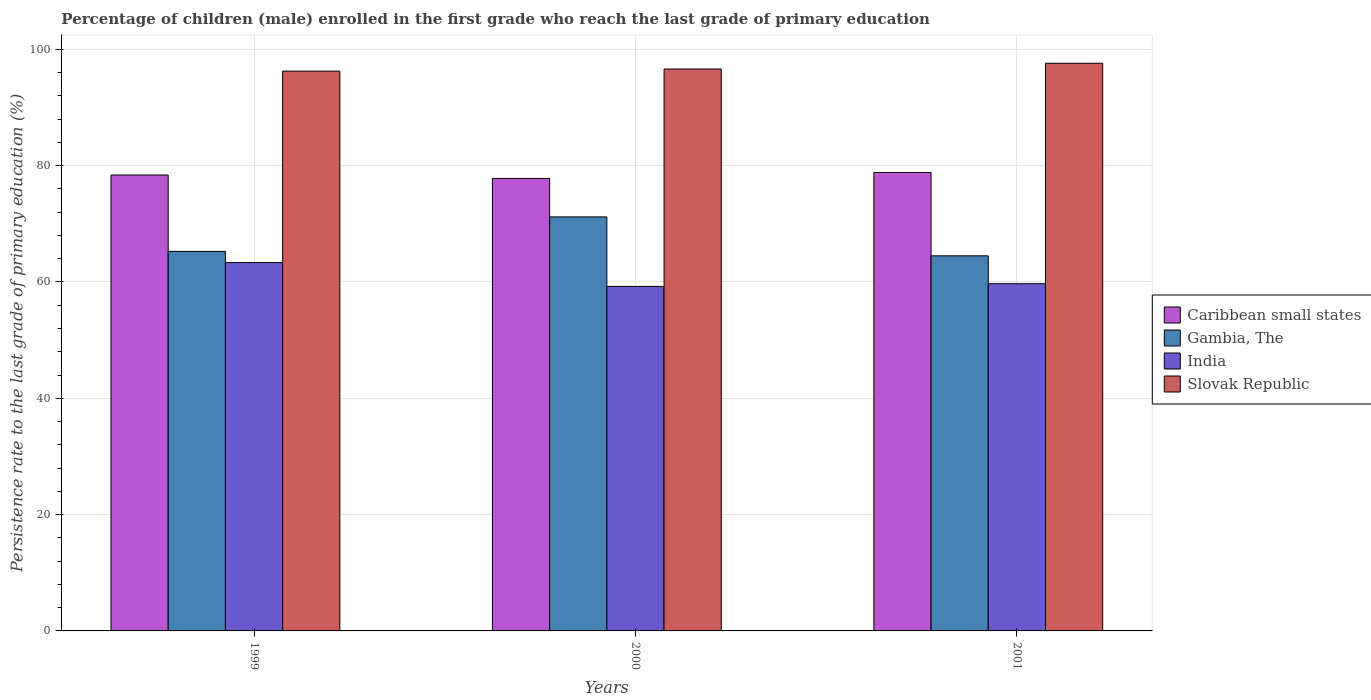Are the number of bars per tick equal to the number of legend labels?
Ensure brevity in your answer.  Yes. How many bars are there on the 3rd tick from the right?
Your response must be concise. 4. What is the persistence rate of children in Gambia, The in 2001?
Your answer should be very brief. 64.49. Across all years, what is the maximum persistence rate of children in Slovak Republic?
Offer a terse response. 97.6. Across all years, what is the minimum persistence rate of children in Gambia, The?
Your response must be concise. 64.49. What is the total persistence rate of children in India in the graph?
Provide a succinct answer. 182.26. What is the difference between the persistence rate of children in Gambia, The in 1999 and that in 2000?
Offer a terse response. -5.93. What is the difference between the persistence rate of children in India in 2000 and the persistence rate of children in Caribbean small states in 2001?
Keep it short and to the point. -19.59. What is the average persistence rate of children in Gambia, The per year?
Ensure brevity in your answer.  66.98. In the year 2000, what is the difference between the persistence rate of children in Gambia, The and persistence rate of children in Caribbean small states?
Offer a terse response. -6.61. In how many years, is the persistence rate of children in Slovak Republic greater than 48 %?
Make the answer very short. 3. What is the ratio of the persistence rate of children in Gambia, The in 2000 to that in 2001?
Provide a short and direct response. 1.1. Is the persistence rate of children in Caribbean small states in 1999 less than that in 2000?
Offer a very short reply. No. Is the difference between the persistence rate of children in Gambia, The in 2000 and 2001 greater than the difference between the persistence rate of children in Caribbean small states in 2000 and 2001?
Your response must be concise. Yes. What is the difference between the highest and the second highest persistence rate of children in Caribbean small states?
Your answer should be very brief. 0.44. What is the difference between the highest and the lowest persistence rate of children in Slovak Republic?
Ensure brevity in your answer.  1.35. In how many years, is the persistence rate of children in Gambia, The greater than the average persistence rate of children in Gambia, The taken over all years?
Your response must be concise. 1. What does the 4th bar from the left in 2000 represents?
Make the answer very short. Slovak Republic. What does the 2nd bar from the right in 2000 represents?
Ensure brevity in your answer.  India. Is it the case that in every year, the sum of the persistence rate of children in India and persistence rate of children in Gambia, The is greater than the persistence rate of children in Slovak Republic?
Offer a terse response. Yes. What is the difference between two consecutive major ticks on the Y-axis?
Give a very brief answer. 20. Does the graph contain any zero values?
Give a very brief answer. No. Does the graph contain grids?
Keep it short and to the point. Yes. How many legend labels are there?
Give a very brief answer. 4. What is the title of the graph?
Your response must be concise. Percentage of children (male) enrolled in the first grade who reach the last grade of primary education. What is the label or title of the X-axis?
Make the answer very short. Years. What is the label or title of the Y-axis?
Offer a terse response. Persistence rate to the last grade of primary education (%). What is the Persistence rate to the last grade of primary education (%) of Caribbean small states in 1999?
Offer a terse response. 78.39. What is the Persistence rate to the last grade of primary education (%) in Gambia, The in 1999?
Offer a terse response. 65.26. What is the Persistence rate to the last grade of primary education (%) of India in 1999?
Offer a terse response. 63.33. What is the Persistence rate to the last grade of primary education (%) in Slovak Republic in 1999?
Give a very brief answer. 96.26. What is the Persistence rate to the last grade of primary education (%) of Caribbean small states in 2000?
Provide a short and direct response. 77.79. What is the Persistence rate to the last grade of primary education (%) in Gambia, The in 2000?
Your answer should be very brief. 71.19. What is the Persistence rate to the last grade of primary education (%) of India in 2000?
Give a very brief answer. 59.23. What is the Persistence rate to the last grade of primary education (%) of Slovak Republic in 2000?
Give a very brief answer. 96.62. What is the Persistence rate to the last grade of primary education (%) of Caribbean small states in 2001?
Your response must be concise. 78.83. What is the Persistence rate to the last grade of primary education (%) of Gambia, The in 2001?
Provide a succinct answer. 64.49. What is the Persistence rate to the last grade of primary education (%) in India in 2001?
Your answer should be very brief. 59.71. What is the Persistence rate to the last grade of primary education (%) of Slovak Republic in 2001?
Your response must be concise. 97.6. Across all years, what is the maximum Persistence rate to the last grade of primary education (%) of Caribbean small states?
Give a very brief answer. 78.83. Across all years, what is the maximum Persistence rate to the last grade of primary education (%) in Gambia, The?
Offer a terse response. 71.19. Across all years, what is the maximum Persistence rate to the last grade of primary education (%) in India?
Offer a terse response. 63.33. Across all years, what is the maximum Persistence rate to the last grade of primary education (%) in Slovak Republic?
Your answer should be very brief. 97.6. Across all years, what is the minimum Persistence rate to the last grade of primary education (%) in Caribbean small states?
Make the answer very short. 77.79. Across all years, what is the minimum Persistence rate to the last grade of primary education (%) in Gambia, The?
Offer a terse response. 64.49. Across all years, what is the minimum Persistence rate to the last grade of primary education (%) of India?
Make the answer very short. 59.23. Across all years, what is the minimum Persistence rate to the last grade of primary education (%) in Slovak Republic?
Ensure brevity in your answer.  96.26. What is the total Persistence rate to the last grade of primary education (%) of Caribbean small states in the graph?
Provide a short and direct response. 235.01. What is the total Persistence rate to the last grade of primary education (%) in Gambia, The in the graph?
Offer a very short reply. 200.94. What is the total Persistence rate to the last grade of primary education (%) of India in the graph?
Your response must be concise. 182.26. What is the total Persistence rate to the last grade of primary education (%) of Slovak Republic in the graph?
Make the answer very short. 290.47. What is the difference between the Persistence rate to the last grade of primary education (%) of Caribbean small states in 1999 and that in 2000?
Your response must be concise. 0.59. What is the difference between the Persistence rate to the last grade of primary education (%) in Gambia, The in 1999 and that in 2000?
Offer a very short reply. -5.93. What is the difference between the Persistence rate to the last grade of primary education (%) of India in 1999 and that in 2000?
Your answer should be very brief. 4.09. What is the difference between the Persistence rate to the last grade of primary education (%) of Slovak Republic in 1999 and that in 2000?
Provide a succinct answer. -0.36. What is the difference between the Persistence rate to the last grade of primary education (%) in Caribbean small states in 1999 and that in 2001?
Offer a very short reply. -0.44. What is the difference between the Persistence rate to the last grade of primary education (%) of Gambia, The in 1999 and that in 2001?
Make the answer very short. 0.77. What is the difference between the Persistence rate to the last grade of primary education (%) of India in 1999 and that in 2001?
Your response must be concise. 3.62. What is the difference between the Persistence rate to the last grade of primary education (%) in Slovak Republic in 1999 and that in 2001?
Provide a short and direct response. -1.35. What is the difference between the Persistence rate to the last grade of primary education (%) of Caribbean small states in 2000 and that in 2001?
Your answer should be compact. -1.03. What is the difference between the Persistence rate to the last grade of primary education (%) in Gambia, The in 2000 and that in 2001?
Provide a succinct answer. 6.7. What is the difference between the Persistence rate to the last grade of primary education (%) of India in 2000 and that in 2001?
Your response must be concise. -0.47. What is the difference between the Persistence rate to the last grade of primary education (%) of Slovak Republic in 2000 and that in 2001?
Ensure brevity in your answer.  -0.99. What is the difference between the Persistence rate to the last grade of primary education (%) in Caribbean small states in 1999 and the Persistence rate to the last grade of primary education (%) in Gambia, The in 2000?
Keep it short and to the point. 7.2. What is the difference between the Persistence rate to the last grade of primary education (%) in Caribbean small states in 1999 and the Persistence rate to the last grade of primary education (%) in India in 2000?
Keep it short and to the point. 19.15. What is the difference between the Persistence rate to the last grade of primary education (%) in Caribbean small states in 1999 and the Persistence rate to the last grade of primary education (%) in Slovak Republic in 2000?
Give a very brief answer. -18.23. What is the difference between the Persistence rate to the last grade of primary education (%) of Gambia, The in 1999 and the Persistence rate to the last grade of primary education (%) of India in 2000?
Provide a succinct answer. 6.03. What is the difference between the Persistence rate to the last grade of primary education (%) of Gambia, The in 1999 and the Persistence rate to the last grade of primary education (%) of Slovak Republic in 2000?
Make the answer very short. -31.36. What is the difference between the Persistence rate to the last grade of primary education (%) in India in 1999 and the Persistence rate to the last grade of primary education (%) in Slovak Republic in 2000?
Provide a short and direct response. -33.29. What is the difference between the Persistence rate to the last grade of primary education (%) in Caribbean small states in 1999 and the Persistence rate to the last grade of primary education (%) in Gambia, The in 2001?
Ensure brevity in your answer.  13.9. What is the difference between the Persistence rate to the last grade of primary education (%) of Caribbean small states in 1999 and the Persistence rate to the last grade of primary education (%) of India in 2001?
Your answer should be very brief. 18.68. What is the difference between the Persistence rate to the last grade of primary education (%) of Caribbean small states in 1999 and the Persistence rate to the last grade of primary education (%) of Slovak Republic in 2001?
Your response must be concise. -19.22. What is the difference between the Persistence rate to the last grade of primary education (%) in Gambia, The in 1999 and the Persistence rate to the last grade of primary education (%) in India in 2001?
Offer a terse response. 5.55. What is the difference between the Persistence rate to the last grade of primary education (%) in Gambia, The in 1999 and the Persistence rate to the last grade of primary education (%) in Slovak Republic in 2001?
Your answer should be compact. -32.34. What is the difference between the Persistence rate to the last grade of primary education (%) of India in 1999 and the Persistence rate to the last grade of primary education (%) of Slovak Republic in 2001?
Provide a short and direct response. -34.28. What is the difference between the Persistence rate to the last grade of primary education (%) of Caribbean small states in 2000 and the Persistence rate to the last grade of primary education (%) of Gambia, The in 2001?
Offer a very short reply. 13.3. What is the difference between the Persistence rate to the last grade of primary education (%) of Caribbean small states in 2000 and the Persistence rate to the last grade of primary education (%) of India in 2001?
Provide a succinct answer. 18.09. What is the difference between the Persistence rate to the last grade of primary education (%) in Caribbean small states in 2000 and the Persistence rate to the last grade of primary education (%) in Slovak Republic in 2001?
Your answer should be very brief. -19.81. What is the difference between the Persistence rate to the last grade of primary education (%) of Gambia, The in 2000 and the Persistence rate to the last grade of primary education (%) of India in 2001?
Provide a short and direct response. 11.48. What is the difference between the Persistence rate to the last grade of primary education (%) of Gambia, The in 2000 and the Persistence rate to the last grade of primary education (%) of Slovak Republic in 2001?
Provide a succinct answer. -26.42. What is the difference between the Persistence rate to the last grade of primary education (%) in India in 2000 and the Persistence rate to the last grade of primary education (%) in Slovak Republic in 2001?
Keep it short and to the point. -38.37. What is the average Persistence rate to the last grade of primary education (%) of Caribbean small states per year?
Your answer should be compact. 78.34. What is the average Persistence rate to the last grade of primary education (%) in Gambia, The per year?
Ensure brevity in your answer.  66.98. What is the average Persistence rate to the last grade of primary education (%) in India per year?
Keep it short and to the point. 60.75. What is the average Persistence rate to the last grade of primary education (%) in Slovak Republic per year?
Keep it short and to the point. 96.82. In the year 1999, what is the difference between the Persistence rate to the last grade of primary education (%) in Caribbean small states and Persistence rate to the last grade of primary education (%) in Gambia, The?
Make the answer very short. 13.13. In the year 1999, what is the difference between the Persistence rate to the last grade of primary education (%) in Caribbean small states and Persistence rate to the last grade of primary education (%) in India?
Provide a succinct answer. 15.06. In the year 1999, what is the difference between the Persistence rate to the last grade of primary education (%) in Caribbean small states and Persistence rate to the last grade of primary education (%) in Slovak Republic?
Give a very brief answer. -17.87. In the year 1999, what is the difference between the Persistence rate to the last grade of primary education (%) in Gambia, The and Persistence rate to the last grade of primary education (%) in India?
Offer a very short reply. 1.93. In the year 1999, what is the difference between the Persistence rate to the last grade of primary education (%) of Gambia, The and Persistence rate to the last grade of primary education (%) of Slovak Republic?
Your answer should be compact. -31. In the year 1999, what is the difference between the Persistence rate to the last grade of primary education (%) of India and Persistence rate to the last grade of primary education (%) of Slovak Republic?
Offer a very short reply. -32.93. In the year 2000, what is the difference between the Persistence rate to the last grade of primary education (%) in Caribbean small states and Persistence rate to the last grade of primary education (%) in Gambia, The?
Make the answer very short. 6.61. In the year 2000, what is the difference between the Persistence rate to the last grade of primary education (%) in Caribbean small states and Persistence rate to the last grade of primary education (%) in India?
Your response must be concise. 18.56. In the year 2000, what is the difference between the Persistence rate to the last grade of primary education (%) of Caribbean small states and Persistence rate to the last grade of primary education (%) of Slovak Republic?
Provide a succinct answer. -18.82. In the year 2000, what is the difference between the Persistence rate to the last grade of primary education (%) of Gambia, The and Persistence rate to the last grade of primary education (%) of India?
Your answer should be very brief. 11.95. In the year 2000, what is the difference between the Persistence rate to the last grade of primary education (%) in Gambia, The and Persistence rate to the last grade of primary education (%) in Slovak Republic?
Your response must be concise. -25.43. In the year 2000, what is the difference between the Persistence rate to the last grade of primary education (%) of India and Persistence rate to the last grade of primary education (%) of Slovak Republic?
Keep it short and to the point. -37.38. In the year 2001, what is the difference between the Persistence rate to the last grade of primary education (%) of Caribbean small states and Persistence rate to the last grade of primary education (%) of Gambia, The?
Ensure brevity in your answer.  14.34. In the year 2001, what is the difference between the Persistence rate to the last grade of primary education (%) of Caribbean small states and Persistence rate to the last grade of primary education (%) of India?
Offer a terse response. 19.12. In the year 2001, what is the difference between the Persistence rate to the last grade of primary education (%) of Caribbean small states and Persistence rate to the last grade of primary education (%) of Slovak Republic?
Offer a very short reply. -18.78. In the year 2001, what is the difference between the Persistence rate to the last grade of primary education (%) of Gambia, The and Persistence rate to the last grade of primary education (%) of India?
Your response must be concise. 4.79. In the year 2001, what is the difference between the Persistence rate to the last grade of primary education (%) of Gambia, The and Persistence rate to the last grade of primary education (%) of Slovak Republic?
Keep it short and to the point. -33.11. In the year 2001, what is the difference between the Persistence rate to the last grade of primary education (%) in India and Persistence rate to the last grade of primary education (%) in Slovak Republic?
Keep it short and to the point. -37.9. What is the ratio of the Persistence rate to the last grade of primary education (%) of Caribbean small states in 1999 to that in 2000?
Offer a very short reply. 1.01. What is the ratio of the Persistence rate to the last grade of primary education (%) in India in 1999 to that in 2000?
Your answer should be very brief. 1.07. What is the ratio of the Persistence rate to the last grade of primary education (%) in Slovak Republic in 1999 to that in 2000?
Keep it short and to the point. 1. What is the ratio of the Persistence rate to the last grade of primary education (%) in Caribbean small states in 1999 to that in 2001?
Your answer should be very brief. 0.99. What is the ratio of the Persistence rate to the last grade of primary education (%) of Gambia, The in 1999 to that in 2001?
Keep it short and to the point. 1.01. What is the ratio of the Persistence rate to the last grade of primary education (%) of India in 1999 to that in 2001?
Offer a very short reply. 1.06. What is the ratio of the Persistence rate to the last grade of primary education (%) of Slovak Republic in 1999 to that in 2001?
Make the answer very short. 0.99. What is the ratio of the Persistence rate to the last grade of primary education (%) in Caribbean small states in 2000 to that in 2001?
Provide a short and direct response. 0.99. What is the ratio of the Persistence rate to the last grade of primary education (%) of Gambia, The in 2000 to that in 2001?
Provide a succinct answer. 1.1. What is the difference between the highest and the second highest Persistence rate to the last grade of primary education (%) of Caribbean small states?
Your answer should be compact. 0.44. What is the difference between the highest and the second highest Persistence rate to the last grade of primary education (%) in Gambia, The?
Keep it short and to the point. 5.93. What is the difference between the highest and the second highest Persistence rate to the last grade of primary education (%) in India?
Offer a very short reply. 3.62. What is the difference between the highest and the lowest Persistence rate to the last grade of primary education (%) of Caribbean small states?
Provide a short and direct response. 1.03. What is the difference between the highest and the lowest Persistence rate to the last grade of primary education (%) in Gambia, The?
Give a very brief answer. 6.7. What is the difference between the highest and the lowest Persistence rate to the last grade of primary education (%) in India?
Give a very brief answer. 4.09. What is the difference between the highest and the lowest Persistence rate to the last grade of primary education (%) in Slovak Republic?
Provide a succinct answer. 1.35. 